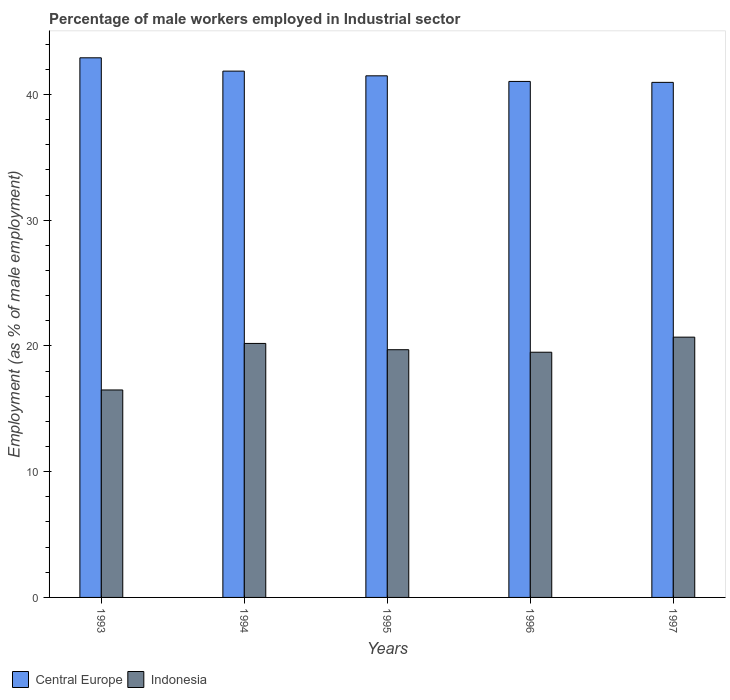How many different coloured bars are there?
Make the answer very short. 2. How many groups of bars are there?
Your response must be concise. 5. Are the number of bars per tick equal to the number of legend labels?
Ensure brevity in your answer.  Yes. How many bars are there on the 1st tick from the right?
Provide a succinct answer. 2. What is the label of the 4th group of bars from the left?
Ensure brevity in your answer.  1996. What is the percentage of male workers employed in Industrial sector in Indonesia in 1994?
Offer a terse response. 20.2. Across all years, what is the maximum percentage of male workers employed in Industrial sector in Indonesia?
Offer a very short reply. 20.7. Across all years, what is the minimum percentage of male workers employed in Industrial sector in Central Europe?
Provide a succinct answer. 40.96. In which year was the percentage of male workers employed in Industrial sector in Indonesia minimum?
Your answer should be compact. 1993. What is the total percentage of male workers employed in Industrial sector in Indonesia in the graph?
Provide a succinct answer. 96.6. What is the difference between the percentage of male workers employed in Industrial sector in Central Europe in 1993 and that in 1995?
Provide a short and direct response. 1.43. What is the difference between the percentage of male workers employed in Industrial sector in Central Europe in 1997 and the percentage of male workers employed in Industrial sector in Indonesia in 1996?
Offer a terse response. 21.46. What is the average percentage of male workers employed in Industrial sector in Indonesia per year?
Offer a terse response. 19.32. In the year 1995, what is the difference between the percentage of male workers employed in Industrial sector in Indonesia and percentage of male workers employed in Industrial sector in Central Europe?
Offer a terse response. -21.78. In how many years, is the percentage of male workers employed in Industrial sector in Indonesia greater than 30 %?
Provide a short and direct response. 0. What is the ratio of the percentage of male workers employed in Industrial sector in Indonesia in 1993 to that in 1997?
Keep it short and to the point. 0.8. Is the difference between the percentage of male workers employed in Industrial sector in Indonesia in 1994 and 1997 greater than the difference between the percentage of male workers employed in Industrial sector in Central Europe in 1994 and 1997?
Your answer should be compact. No. What is the difference between the highest and the second highest percentage of male workers employed in Industrial sector in Indonesia?
Offer a terse response. 0.5. What is the difference between the highest and the lowest percentage of male workers employed in Industrial sector in Central Europe?
Offer a terse response. 1.95. In how many years, is the percentage of male workers employed in Industrial sector in Indonesia greater than the average percentage of male workers employed in Industrial sector in Indonesia taken over all years?
Offer a terse response. 4. What does the 1st bar from the left in 1994 represents?
Offer a terse response. Central Europe. What does the 2nd bar from the right in 1993 represents?
Ensure brevity in your answer.  Central Europe. How many bars are there?
Give a very brief answer. 10. What is the difference between two consecutive major ticks on the Y-axis?
Make the answer very short. 10. Are the values on the major ticks of Y-axis written in scientific E-notation?
Provide a short and direct response. No. Does the graph contain any zero values?
Make the answer very short. No. How many legend labels are there?
Provide a succinct answer. 2. What is the title of the graph?
Your response must be concise. Percentage of male workers employed in Industrial sector. Does "Colombia" appear as one of the legend labels in the graph?
Ensure brevity in your answer.  No. What is the label or title of the X-axis?
Ensure brevity in your answer.  Years. What is the label or title of the Y-axis?
Give a very brief answer. Employment (as % of male employment). What is the Employment (as % of male employment) of Central Europe in 1993?
Provide a succinct answer. 42.92. What is the Employment (as % of male employment) in Central Europe in 1994?
Your answer should be very brief. 41.86. What is the Employment (as % of male employment) of Indonesia in 1994?
Provide a succinct answer. 20.2. What is the Employment (as % of male employment) in Central Europe in 1995?
Give a very brief answer. 41.48. What is the Employment (as % of male employment) of Indonesia in 1995?
Make the answer very short. 19.7. What is the Employment (as % of male employment) of Central Europe in 1996?
Provide a short and direct response. 41.04. What is the Employment (as % of male employment) in Central Europe in 1997?
Provide a succinct answer. 40.96. What is the Employment (as % of male employment) in Indonesia in 1997?
Provide a succinct answer. 20.7. Across all years, what is the maximum Employment (as % of male employment) in Central Europe?
Offer a terse response. 42.92. Across all years, what is the maximum Employment (as % of male employment) in Indonesia?
Ensure brevity in your answer.  20.7. Across all years, what is the minimum Employment (as % of male employment) in Central Europe?
Provide a short and direct response. 40.96. Across all years, what is the minimum Employment (as % of male employment) of Indonesia?
Offer a terse response. 16.5. What is the total Employment (as % of male employment) in Central Europe in the graph?
Your response must be concise. 208.25. What is the total Employment (as % of male employment) of Indonesia in the graph?
Your answer should be very brief. 96.6. What is the difference between the Employment (as % of male employment) of Central Europe in 1993 and that in 1994?
Give a very brief answer. 1.06. What is the difference between the Employment (as % of male employment) in Central Europe in 1993 and that in 1995?
Give a very brief answer. 1.43. What is the difference between the Employment (as % of male employment) in Indonesia in 1993 and that in 1995?
Offer a terse response. -3.2. What is the difference between the Employment (as % of male employment) of Central Europe in 1993 and that in 1996?
Make the answer very short. 1.88. What is the difference between the Employment (as % of male employment) of Indonesia in 1993 and that in 1996?
Ensure brevity in your answer.  -3. What is the difference between the Employment (as % of male employment) in Central Europe in 1993 and that in 1997?
Your answer should be very brief. 1.95. What is the difference between the Employment (as % of male employment) of Central Europe in 1994 and that in 1995?
Offer a very short reply. 0.37. What is the difference between the Employment (as % of male employment) in Indonesia in 1994 and that in 1995?
Your response must be concise. 0.5. What is the difference between the Employment (as % of male employment) in Central Europe in 1994 and that in 1996?
Keep it short and to the point. 0.82. What is the difference between the Employment (as % of male employment) of Central Europe in 1994 and that in 1997?
Your response must be concise. 0.9. What is the difference between the Employment (as % of male employment) in Central Europe in 1995 and that in 1996?
Make the answer very short. 0.45. What is the difference between the Employment (as % of male employment) in Indonesia in 1995 and that in 1996?
Offer a terse response. 0.2. What is the difference between the Employment (as % of male employment) of Central Europe in 1995 and that in 1997?
Provide a short and direct response. 0.52. What is the difference between the Employment (as % of male employment) in Indonesia in 1995 and that in 1997?
Keep it short and to the point. -1. What is the difference between the Employment (as % of male employment) of Central Europe in 1996 and that in 1997?
Give a very brief answer. 0.07. What is the difference between the Employment (as % of male employment) in Central Europe in 1993 and the Employment (as % of male employment) in Indonesia in 1994?
Provide a short and direct response. 22.72. What is the difference between the Employment (as % of male employment) of Central Europe in 1993 and the Employment (as % of male employment) of Indonesia in 1995?
Offer a terse response. 23.22. What is the difference between the Employment (as % of male employment) of Central Europe in 1993 and the Employment (as % of male employment) of Indonesia in 1996?
Your answer should be very brief. 23.42. What is the difference between the Employment (as % of male employment) in Central Europe in 1993 and the Employment (as % of male employment) in Indonesia in 1997?
Give a very brief answer. 22.22. What is the difference between the Employment (as % of male employment) of Central Europe in 1994 and the Employment (as % of male employment) of Indonesia in 1995?
Your answer should be compact. 22.16. What is the difference between the Employment (as % of male employment) of Central Europe in 1994 and the Employment (as % of male employment) of Indonesia in 1996?
Provide a short and direct response. 22.36. What is the difference between the Employment (as % of male employment) in Central Europe in 1994 and the Employment (as % of male employment) in Indonesia in 1997?
Provide a succinct answer. 21.16. What is the difference between the Employment (as % of male employment) in Central Europe in 1995 and the Employment (as % of male employment) in Indonesia in 1996?
Provide a succinct answer. 21.98. What is the difference between the Employment (as % of male employment) of Central Europe in 1995 and the Employment (as % of male employment) of Indonesia in 1997?
Make the answer very short. 20.78. What is the difference between the Employment (as % of male employment) in Central Europe in 1996 and the Employment (as % of male employment) in Indonesia in 1997?
Your answer should be compact. 20.34. What is the average Employment (as % of male employment) in Central Europe per year?
Ensure brevity in your answer.  41.65. What is the average Employment (as % of male employment) in Indonesia per year?
Your answer should be compact. 19.32. In the year 1993, what is the difference between the Employment (as % of male employment) of Central Europe and Employment (as % of male employment) of Indonesia?
Offer a terse response. 26.42. In the year 1994, what is the difference between the Employment (as % of male employment) of Central Europe and Employment (as % of male employment) of Indonesia?
Offer a very short reply. 21.66. In the year 1995, what is the difference between the Employment (as % of male employment) in Central Europe and Employment (as % of male employment) in Indonesia?
Give a very brief answer. 21.78. In the year 1996, what is the difference between the Employment (as % of male employment) of Central Europe and Employment (as % of male employment) of Indonesia?
Your response must be concise. 21.54. In the year 1997, what is the difference between the Employment (as % of male employment) in Central Europe and Employment (as % of male employment) in Indonesia?
Make the answer very short. 20.26. What is the ratio of the Employment (as % of male employment) in Central Europe in 1993 to that in 1994?
Provide a succinct answer. 1.03. What is the ratio of the Employment (as % of male employment) of Indonesia in 1993 to that in 1994?
Provide a succinct answer. 0.82. What is the ratio of the Employment (as % of male employment) of Central Europe in 1993 to that in 1995?
Make the answer very short. 1.03. What is the ratio of the Employment (as % of male employment) in Indonesia in 1993 to that in 1995?
Provide a short and direct response. 0.84. What is the ratio of the Employment (as % of male employment) of Central Europe in 1993 to that in 1996?
Give a very brief answer. 1.05. What is the ratio of the Employment (as % of male employment) of Indonesia in 1993 to that in 1996?
Your answer should be compact. 0.85. What is the ratio of the Employment (as % of male employment) of Central Europe in 1993 to that in 1997?
Provide a succinct answer. 1.05. What is the ratio of the Employment (as % of male employment) of Indonesia in 1993 to that in 1997?
Offer a very short reply. 0.8. What is the ratio of the Employment (as % of male employment) of Indonesia in 1994 to that in 1995?
Ensure brevity in your answer.  1.03. What is the ratio of the Employment (as % of male employment) of Central Europe in 1994 to that in 1996?
Provide a short and direct response. 1.02. What is the ratio of the Employment (as % of male employment) in Indonesia in 1994 to that in 1996?
Give a very brief answer. 1.04. What is the ratio of the Employment (as % of male employment) in Central Europe in 1994 to that in 1997?
Your answer should be very brief. 1.02. What is the ratio of the Employment (as % of male employment) in Indonesia in 1994 to that in 1997?
Provide a succinct answer. 0.98. What is the ratio of the Employment (as % of male employment) of Central Europe in 1995 to that in 1996?
Offer a very short reply. 1.01. What is the ratio of the Employment (as % of male employment) of Indonesia in 1995 to that in 1996?
Provide a short and direct response. 1.01. What is the ratio of the Employment (as % of male employment) of Central Europe in 1995 to that in 1997?
Give a very brief answer. 1.01. What is the ratio of the Employment (as % of male employment) of Indonesia in 1995 to that in 1997?
Give a very brief answer. 0.95. What is the ratio of the Employment (as % of male employment) of Indonesia in 1996 to that in 1997?
Keep it short and to the point. 0.94. What is the difference between the highest and the second highest Employment (as % of male employment) in Central Europe?
Provide a short and direct response. 1.06. What is the difference between the highest and the lowest Employment (as % of male employment) in Central Europe?
Give a very brief answer. 1.95. 